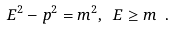<formula> <loc_0><loc_0><loc_500><loc_500>E ^ { 2 } - p ^ { 2 } = m ^ { 2 } , \ E \geq m \ .</formula> 